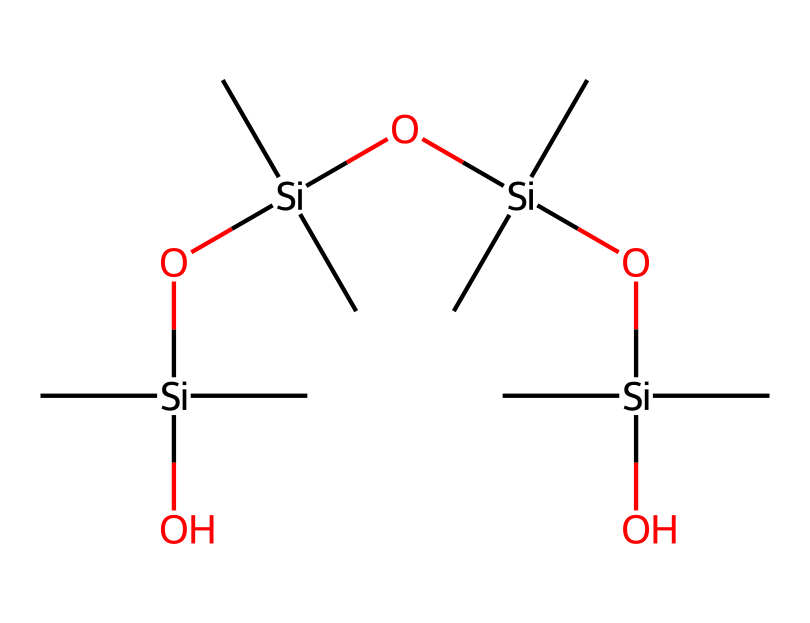how many silicon atoms are present in this structure? The SMILES representation shows four silicon atoms connected through oxygen and carbon groups. Each group of the structure indicates a silicon atom since the "Si" part appears four times.
Answer: four what functional groups are indicated in this chemical structure? The structure indicates that it contains hydroxyl groups (-OH) derived from the silanol functional group, as well as siloxane linkages (Si-O-Si) connecting the silicons.
Answer: silanol, siloxane what is the degree of branching in this organosilicon compound? The structure shows that each silicon atom is connected to three methyl groups and further connected to two other silicons via oxygen, indicating it is highly branched.
Answer: highly branched how many oxygen atoms are present in this chemical structure? By analyzing the SMILES representation, there are three oxygen atoms linking the four silicon atoms and one hydroxyl group. Thus, the total count of oxygen atoms is four.
Answer: four what type of bond connects silicon and oxygen in this structure? The SMILES indicates a siloxane bond (Si-O), which is a covalent bond formed between silicon and oxygen atoms. The representation confirms this bonding pattern.
Answer: covalent which part of the molecule enhances its flexibility in sports drink bottles? The presence of multiple siloxane linkages (Si-O) provides significant flexibility, allowing for the bending and movement of the structure, crucial for bottle durability.
Answer: siloxane linkages what is the general purpose of including organosilicon compounds in sports drink bottle manufacturing? Organosilicon compounds provide chemical stability, flexibility, and durability, which are essential properties for the longevity and usability of sports drink bottles.
Answer: chemical stability, flexibility, durability 